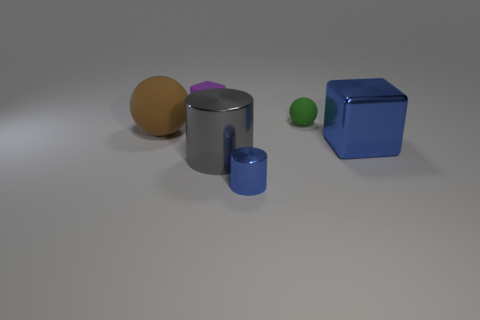What is the color of the tiny matte sphere?
Keep it short and to the point. Green. Are there any tiny things?
Offer a very short reply. Yes. There is a brown sphere; are there any large shiny cubes to the right of it?
Keep it short and to the point. Yes. There is a small green object that is the same shape as the brown matte thing; what material is it?
Keep it short and to the point. Rubber. What number of other things are the same shape as the small purple thing?
Provide a succinct answer. 1. What number of large shiny cubes are in front of the metallic cylinder that is in front of the cylinder left of the blue cylinder?
Provide a short and direct response. 0. How many blue metallic things are the same shape as the brown matte thing?
Offer a very short reply. 0. There is a large metal object that is right of the tiny metallic object; does it have the same color as the small cylinder?
Provide a short and direct response. Yes. What is the shape of the blue metallic object that is on the right side of the small object that is in front of the matte sphere left of the blue shiny cylinder?
Provide a succinct answer. Cube. There is a blue cylinder; is its size the same as the shiny thing on the left side of the small metallic thing?
Your response must be concise. No. 